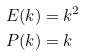Convert formula to latex. <formula><loc_0><loc_0><loc_500><loc_500>E ( k ) & = k ^ { 2 } \\ P ( k ) & = k</formula> 